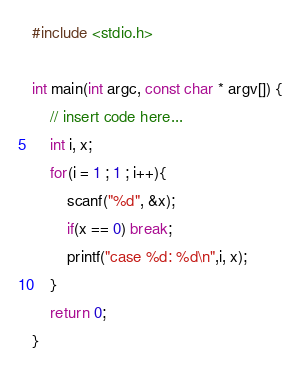<code> <loc_0><loc_0><loc_500><loc_500><_C_>#include <stdio.h>

int main(int argc, const char * argv[]) {
    // insert code here...
    int i, x;
    for(i = 1 ; 1 ; i++){
        scanf("%d", &x);
        if(x == 0) break;
        printf("case %d: %d\n",i, x);
    }
    return 0;
}</code> 